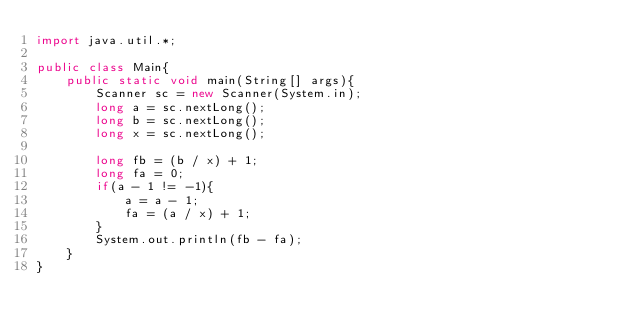<code> <loc_0><loc_0><loc_500><loc_500><_Java_>import java.util.*;

public class Main{
	public static void main(String[] args){
    	Scanner sc = new Scanner(System.in);
      	long a = sc.nextLong();
      	long b = sc.nextLong();
      	long x = sc.nextLong();
      
      	long fb = (b / x) + 1;
 		long fa = 0;
      	if(a - 1 != -1){
          	a = a - 1;
        	fa = (a / x) + 1;
        }
      	System.out.println(fb - fa);
    }
}</code> 